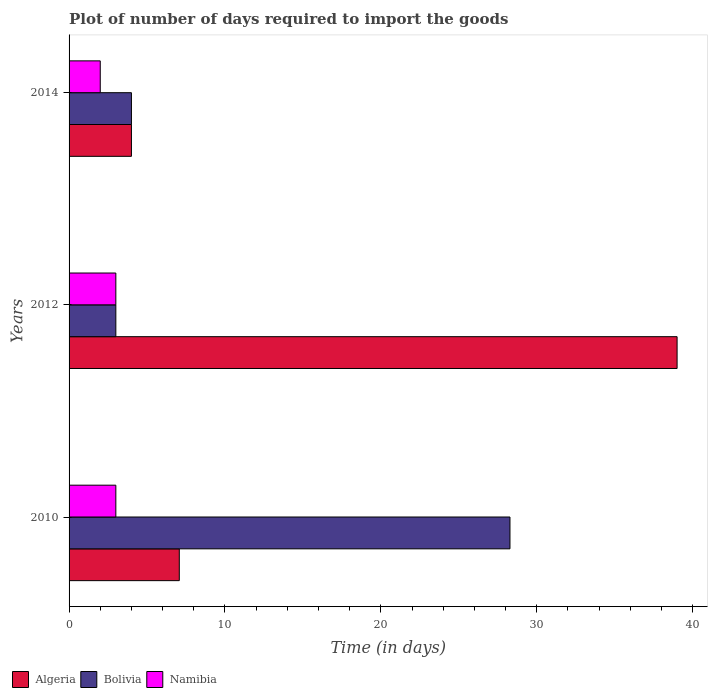How many different coloured bars are there?
Provide a short and direct response. 3. How many groups of bars are there?
Keep it short and to the point. 3. How many bars are there on the 1st tick from the bottom?
Provide a short and direct response. 3. What is the time required to import goods in Bolivia in 2010?
Your answer should be very brief. 28.28. Across all years, what is the maximum time required to import goods in Namibia?
Keep it short and to the point. 3. What is the total time required to import goods in Namibia in the graph?
Your response must be concise. 8. What is the difference between the time required to import goods in Bolivia in 2010 and that in 2012?
Keep it short and to the point. 25.28. What is the difference between the time required to import goods in Bolivia in 2014 and the time required to import goods in Algeria in 2012?
Give a very brief answer. -35. What is the average time required to import goods in Namibia per year?
Offer a very short reply. 2.67. In the year 2012, what is the difference between the time required to import goods in Namibia and time required to import goods in Algeria?
Offer a terse response. -36. What is the ratio of the time required to import goods in Bolivia in 2012 to that in 2014?
Offer a very short reply. 0.75. Is the time required to import goods in Bolivia in 2010 less than that in 2012?
Offer a terse response. No. Is the difference between the time required to import goods in Namibia in 2010 and 2012 greater than the difference between the time required to import goods in Algeria in 2010 and 2012?
Provide a short and direct response. Yes. What is the difference between the highest and the second highest time required to import goods in Algeria?
Offer a terse response. 31.93. In how many years, is the time required to import goods in Namibia greater than the average time required to import goods in Namibia taken over all years?
Ensure brevity in your answer.  2. Is the sum of the time required to import goods in Bolivia in 2012 and 2014 greater than the maximum time required to import goods in Namibia across all years?
Your answer should be very brief. Yes. What does the 3rd bar from the top in 2012 represents?
Offer a very short reply. Algeria. What does the 1st bar from the bottom in 2010 represents?
Keep it short and to the point. Algeria. Is it the case that in every year, the sum of the time required to import goods in Algeria and time required to import goods in Bolivia is greater than the time required to import goods in Namibia?
Keep it short and to the point. Yes. How many bars are there?
Your response must be concise. 9. How many years are there in the graph?
Offer a very short reply. 3. Does the graph contain any zero values?
Provide a short and direct response. No. How are the legend labels stacked?
Ensure brevity in your answer.  Horizontal. What is the title of the graph?
Your response must be concise. Plot of number of days required to import the goods. Does "Jamaica" appear as one of the legend labels in the graph?
Provide a succinct answer. No. What is the label or title of the X-axis?
Offer a terse response. Time (in days). What is the label or title of the Y-axis?
Make the answer very short. Years. What is the Time (in days) of Algeria in 2010?
Make the answer very short. 7.07. What is the Time (in days) of Bolivia in 2010?
Your answer should be very brief. 28.28. What is the Time (in days) of Namibia in 2010?
Provide a short and direct response. 3. What is the Time (in days) of Namibia in 2012?
Provide a succinct answer. 3. What is the Time (in days) of Algeria in 2014?
Offer a terse response. 4. Across all years, what is the maximum Time (in days) in Algeria?
Make the answer very short. 39. Across all years, what is the maximum Time (in days) of Bolivia?
Offer a terse response. 28.28. Across all years, what is the maximum Time (in days) in Namibia?
Your answer should be compact. 3. Across all years, what is the minimum Time (in days) of Algeria?
Your answer should be compact. 4. Across all years, what is the minimum Time (in days) of Bolivia?
Offer a terse response. 3. What is the total Time (in days) of Algeria in the graph?
Make the answer very short. 50.07. What is the total Time (in days) of Bolivia in the graph?
Your answer should be compact. 35.28. What is the total Time (in days) in Namibia in the graph?
Keep it short and to the point. 8. What is the difference between the Time (in days) of Algeria in 2010 and that in 2012?
Provide a short and direct response. -31.93. What is the difference between the Time (in days) in Bolivia in 2010 and that in 2012?
Make the answer very short. 25.28. What is the difference between the Time (in days) of Namibia in 2010 and that in 2012?
Ensure brevity in your answer.  0. What is the difference between the Time (in days) in Algeria in 2010 and that in 2014?
Offer a terse response. 3.07. What is the difference between the Time (in days) in Bolivia in 2010 and that in 2014?
Your response must be concise. 24.28. What is the difference between the Time (in days) in Namibia in 2010 and that in 2014?
Offer a very short reply. 1. What is the difference between the Time (in days) of Algeria in 2012 and that in 2014?
Provide a short and direct response. 35. What is the difference between the Time (in days) in Bolivia in 2012 and that in 2014?
Make the answer very short. -1. What is the difference between the Time (in days) of Namibia in 2012 and that in 2014?
Provide a succinct answer. 1. What is the difference between the Time (in days) in Algeria in 2010 and the Time (in days) in Bolivia in 2012?
Offer a terse response. 4.07. What is the difference between the Time (in days) of Algeria in 2010 and the Time (in days) of Namibia in 2012?
Your answer should be very brief. 4.07. What is the difference between the Time (in days) of Bolivia in 2010 and the Time (in days) of Namibia in 2012?
Offer a terse response. 25.28. What is the difference between the Time (in days) in Algeria in 2010 and the Time (in days) in Bolivia in 2014?
Your answer should be compact. 3.07. What is the difference between the Time (in days) of Algeria in 2010 and the Time (in days) of Namibia in 2014?
Your answer should be compact. 5.07. What is the difference between the Time (in days) of Bolivia in 2010 and the Time (in days) of Namibia in 2014?
Keep it short and to the point. 26.28. What is the difference between the Time (in days) in Algeria in 2012 and the Time (in days) in Bolivia in 2014?
Make the answer very short. 35. What is the difference between the Time (in days) in Algeria in 2012 and the Time (in days) in Namibia in 2014?
Ensure brevity in your answer.  37. What is the difference between the Time (in days) of Bolivia in 2012 and the Time (in days) of Namibia in 2014?
Make the answer very short. 1. What is the average Time (in days) in Algeria per year?
Provide a succinct answer. 16.69. What is the average Time (in days) in Bolivia per year?
Make the answer very short. 11.76. What is the average Time (in days) of Namibia per year?
Your response must be concise. 2.67. In the year 2010, what is the difference between the Time (in days) in Algeria and Time (in days) in Bolivia?
Ensure brevity in your answer.  -21.21. In the year 2010, what is the difference between the Time (in days) in Algeria and Time (in days) in Namibia?
Offer a terse response. 4.07. In the year 2010, what is the difference between the Time (in days) in Bolivia and Time (in days) in Namibia?
Provide a succinct answer. 25.28. In the year 2014, what is the difference between the Time (in days) of Algeria and Time (in days) of Namibia?
Provide a short and direct response. 2. What is the ratio of the Time (in days) in Algeria in 2010 to that in 2012?
Provide a short and direct response. 0.18. What is the ratio of the Time (in days) in Bolivia in 2010 to that in 2012?
Ensure brevity in your answer.  9.43. What is the ratio of the Time (in days) of Namibia in 2010 to that in 2012?
Ensure brevity in your answer.  1. What is the ratio of the Time (in days) of Algeria in 2010 to that in 2014?
Your response must be concise. 1.77. What is the ratio of the Time (in days) of Bolivia in 2010 to that in 2014?
Offer a very short reply. 7.07. What is the ratio of the Time (in days) in Namibia in 2010 to that in 2014?
Your response must be concise. 1.5. What is the ratio of the Time (in days) of Algeria in 2012 to that in 2014?
Ensure brevity in your answer.  9.75. What is the ratio of the Time (in days) of Namibia in 2012 to that in 2014?
Your answer should be compact. 1.5. What is the difference between the highest and the second highest Time (in days) of Algeria?
Provide a succinct answer. 31.93. What is the difference between the highest and the second highest Time (in days) of Bolivia?
Provide a succinct answer. 24.28. What is the difference between the highest and the second highest Time (in days) in Namibia?
Keep it short and to the point. 0. What is the difference between the highest and the lowest Time (in days) in Algeria?
Offer a very short reply. 35. What is the difference between the highest and the lowest Time (in days) of Bolivia?
Offer a very short reply. 25.28. What is the difference between the highest and the lowest Time (in days) of Namibia?
Provide a short and direct response. 1. 